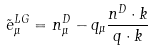<formula> <loc_0><loc_0><loc_500><loc_500>\tilde { e } ^ { L G } _ { \mu } = n ^ { D } _ { \mu } - q _ { \mu } \frac { n ^ { D } \cdot k } { q \cdot k }</formula> 